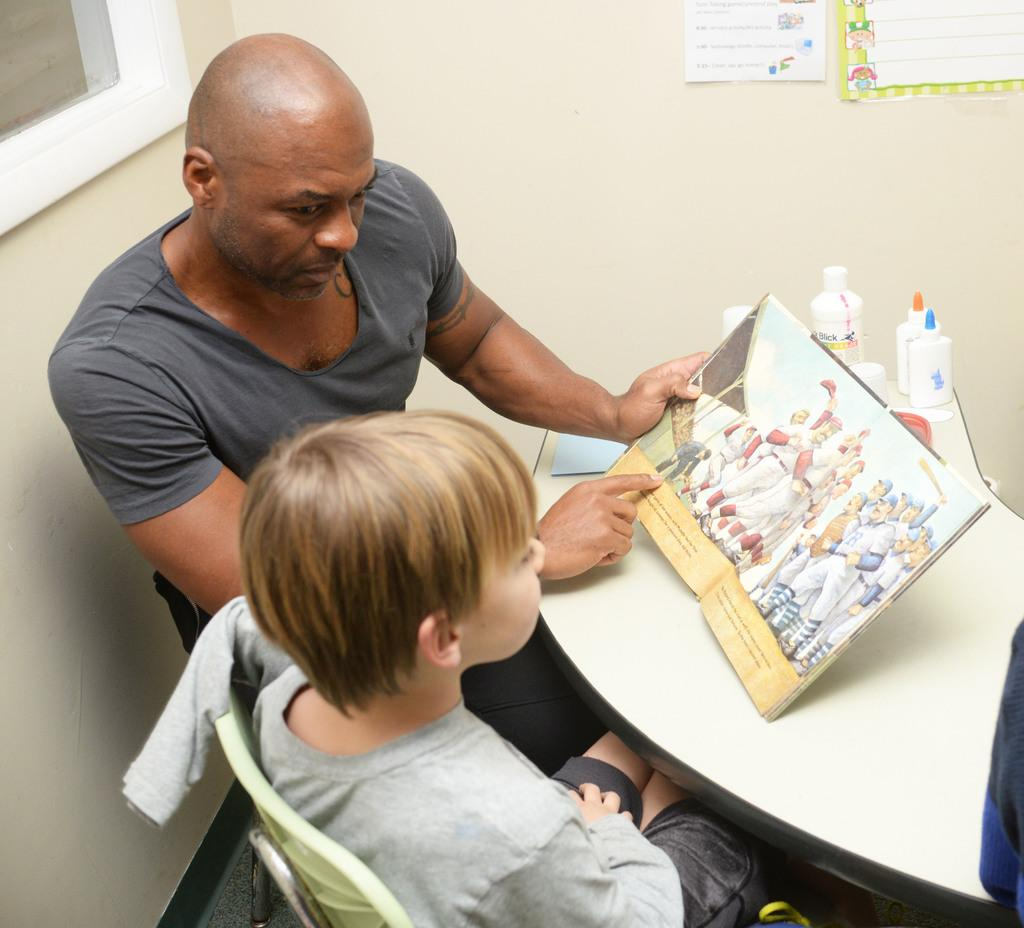What can be seen in the background of the image? There is a wall in the image. What is on the wall in the image? The provided facts do not mention anything on the wall. How many people are present in the image? There are two people sitting on chairs in the image. What is on the table in the image? There is a book and a bottle on the table in the image. What is the people sitting on in the image? The people are sitting on chairs in the image. What type of mountain can be seen in the image? There is no mountain present in the image. How does the organization of the items on the table reflect the people's preferences? The provided facts do not mention any preferences or organization of the items on the table. 